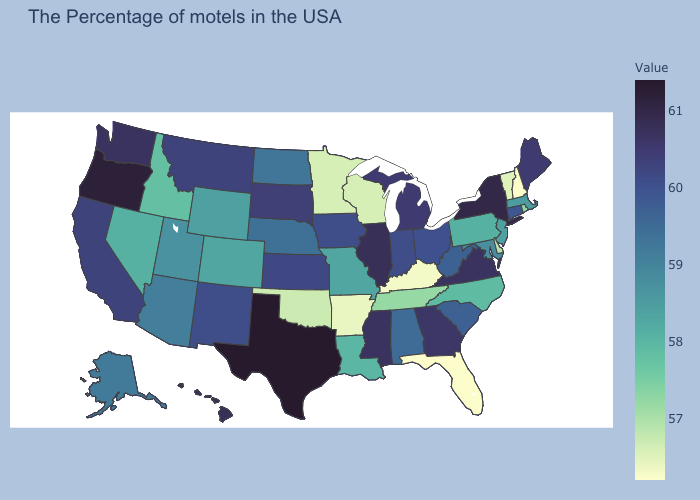Does Pennsylvania have a higher value than Montana?
Quick response, please. No. Does the map have missing data?
Quick response, please. No. Does Louisiana have a lower value than Arizona?
Quick response, please. Yes. Is the legend a continuous bar?
Give a very brief answer. Yes. Does Texas have the highest value in the USA?
Short answer required. Yes. Does New Hampshire have the lowest value in the Northeast?
Answer briefly. Yes. 